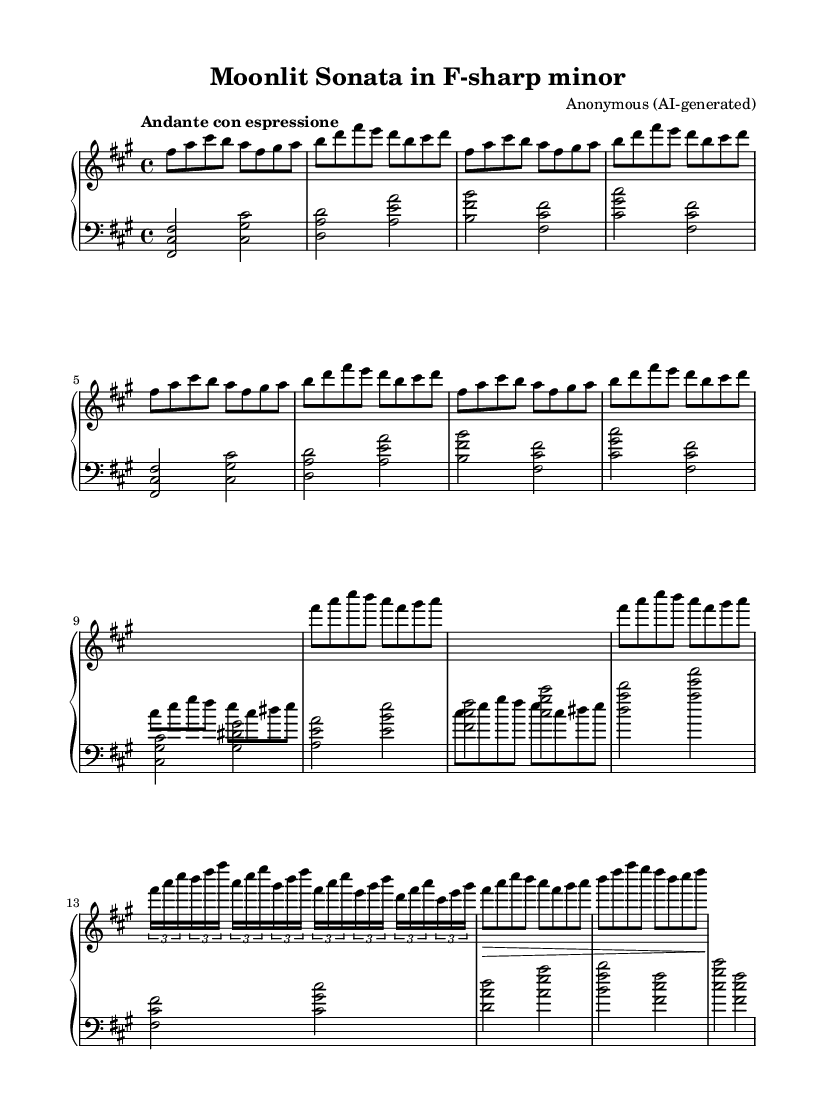What is the key signature of this music? The key signature is indicated by the number of sharps or flats at the beginning of the staff. In this case, the presence of three sharps indicates the key of F-sharp minor.
Answer: F-sharp minor What is the time signature of this composition? The time signature is shown after the key signature and is represented as a fraction. This composition is marked with a 4 over 4 time signature, which means there are four beats per measure.
Answer: 4/4 What is the tempo marking for this piece? The tempo marking, which instructs how fast or slow the piece should be played, is indicated at the beginning of the sheet music. Here, it is marked as "Andante con espressione," suggesting a moderately slow tempo with expression.
Answer: Andante con espressione How many themes are present in this composition? The presence of distinct sections is indicated by labeled parts of the music. There are two main themes: Theme A and Theme B, which can be differentiated in the music structure. Thus, the piece features two themes.
Answer: Two What musical technique is employed in Theme B? The use of cross-hand technique is indicated by changing the staff during Theme B, where the left hand plays notes that would typically be played by the right hand. This emphasizes the complexity and technical precision involved in this section.
Answer: Cross-hand technique How is Theme A varied in the later sections? Theme A is varied with rapid arpeggios, indicated by the grouping of notes within tuplets. This shows an elaboration on the original theme, adding technical complexity and enhancing the performance challenge.
Answer: Rapid arpeggios 